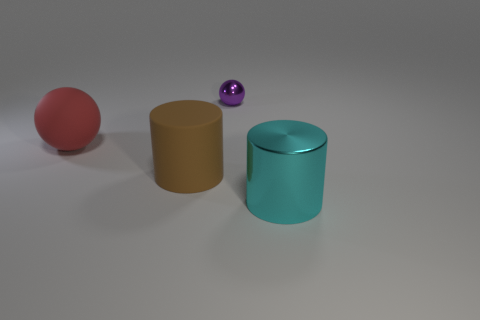Does the big object that is behind the brown rubber thing have the same color as the large matte thing in front of the red rubber object?
Your response must be concise. No. Are there any large objects made of the same material as the large ball?
Offer a terse response. Yes. Are there an equal number of small metallic balls that are in front of the rubber sphere and large cyan cylinders that are in front of the shiny cylinder?
Provide a succinct answer. Yes. There is a matte object in front of the red ball; how big is it?
Your answer should be very brief. Large. There is a big cylinder that is to the left of the object that is right of the shiny ball; what is its material?
Ensure brevity in your answer.  Rubber. There is a metal thing that is behind the large cylinder that is behind the large cyan cylinder; what number of brown rubber cylinders are to the left of it?
Provide a succinct answer. 1. Do the sphere that is on the right side of the red rubber object and the large cylinder left of the big shiny cylinder have the same material?
Your response must be concise. No. What number of red rubber objects are the same shape as the small purple shiny thing?
Your answer should be very brief. 1. Are there more purple objects on the right side of the purple object than cyan things?
Give a very brief answer. No. There is a big object on the right side of the ball that is to the right of the large thing that is behind the brown object; what shape is it?
Offer a terse response. Cylinder. 